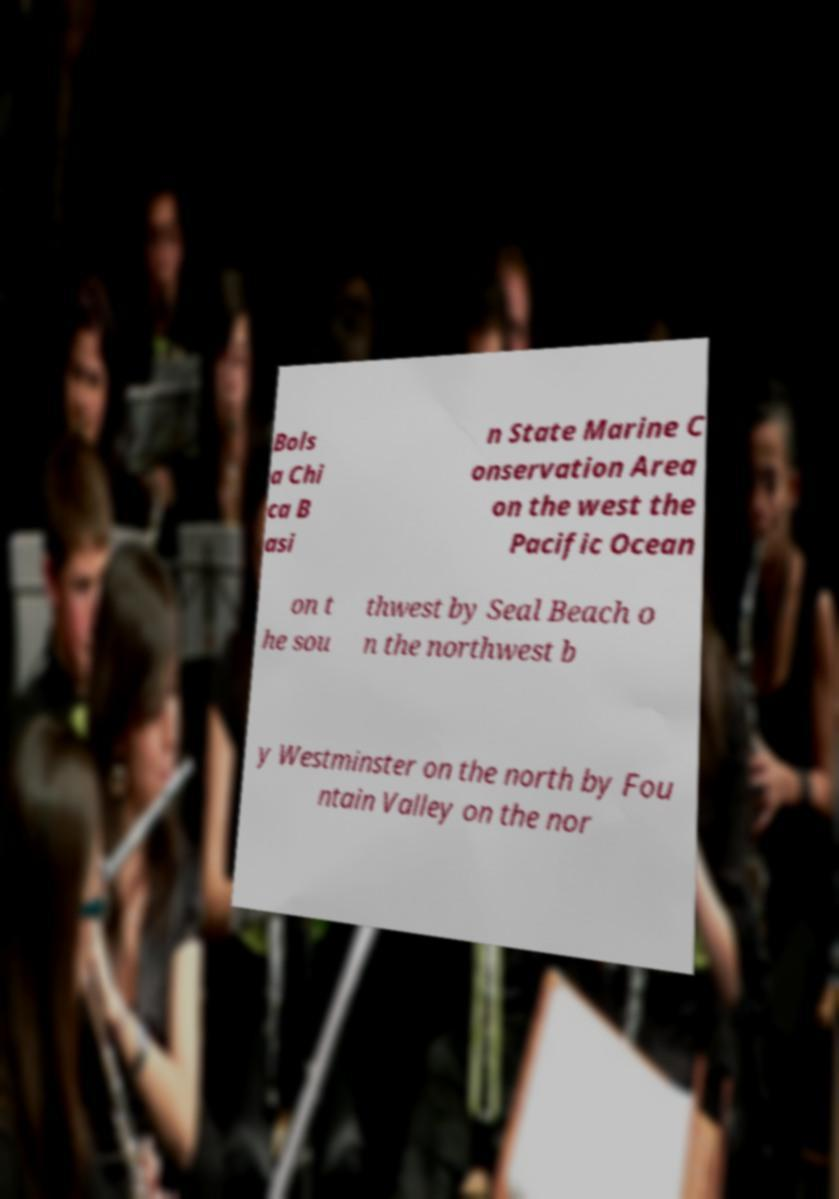I need the written content from this picture converted into text. Can you do that? Bols a Chi ca B asi n State Marine C onservation Area on the west the Pacific Ocean on t he sou thwest by Seal Beach o n the northwest b y Westminster on the north by Fou ntain Valley on the nor 